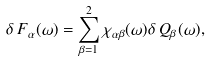Convert formula to latex. <formula><loc_0><loc_0><loc_500><loc_500>\delta \, F _ { \alpha } ( \omega ) = \sum _ { \beta = 1 } ^ { 2 } \chi _ { \alpha \beta } ( \omega ) \delta \, Q _ { \beta } ( \omega ) ,</formula> 